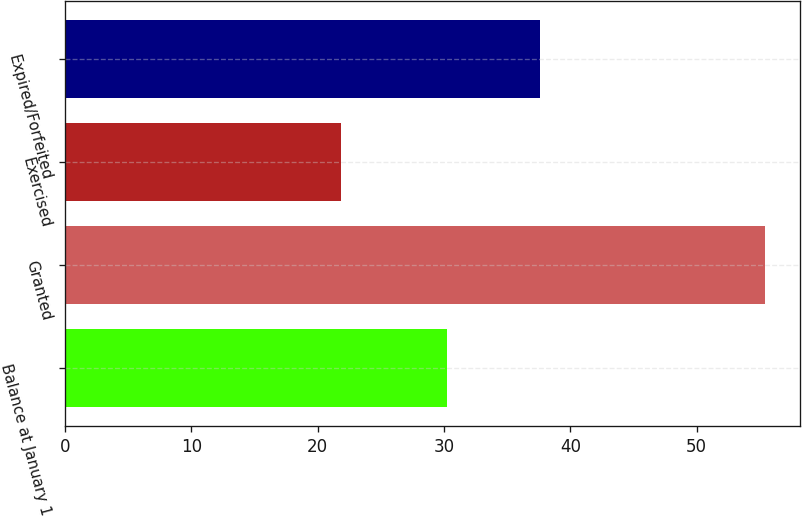Convert chart to OTSL. <chart><loc_0><loc_0><loc_500><loc_500><bar_chart><fcel>Balance at January 1<fcel>Granted<fcel>Exercised<fcel>Expired/Forfeited<nl><fcel>30.22<fcel>55.43<fcel>21.88<fcel>37.61<nl></chart> 